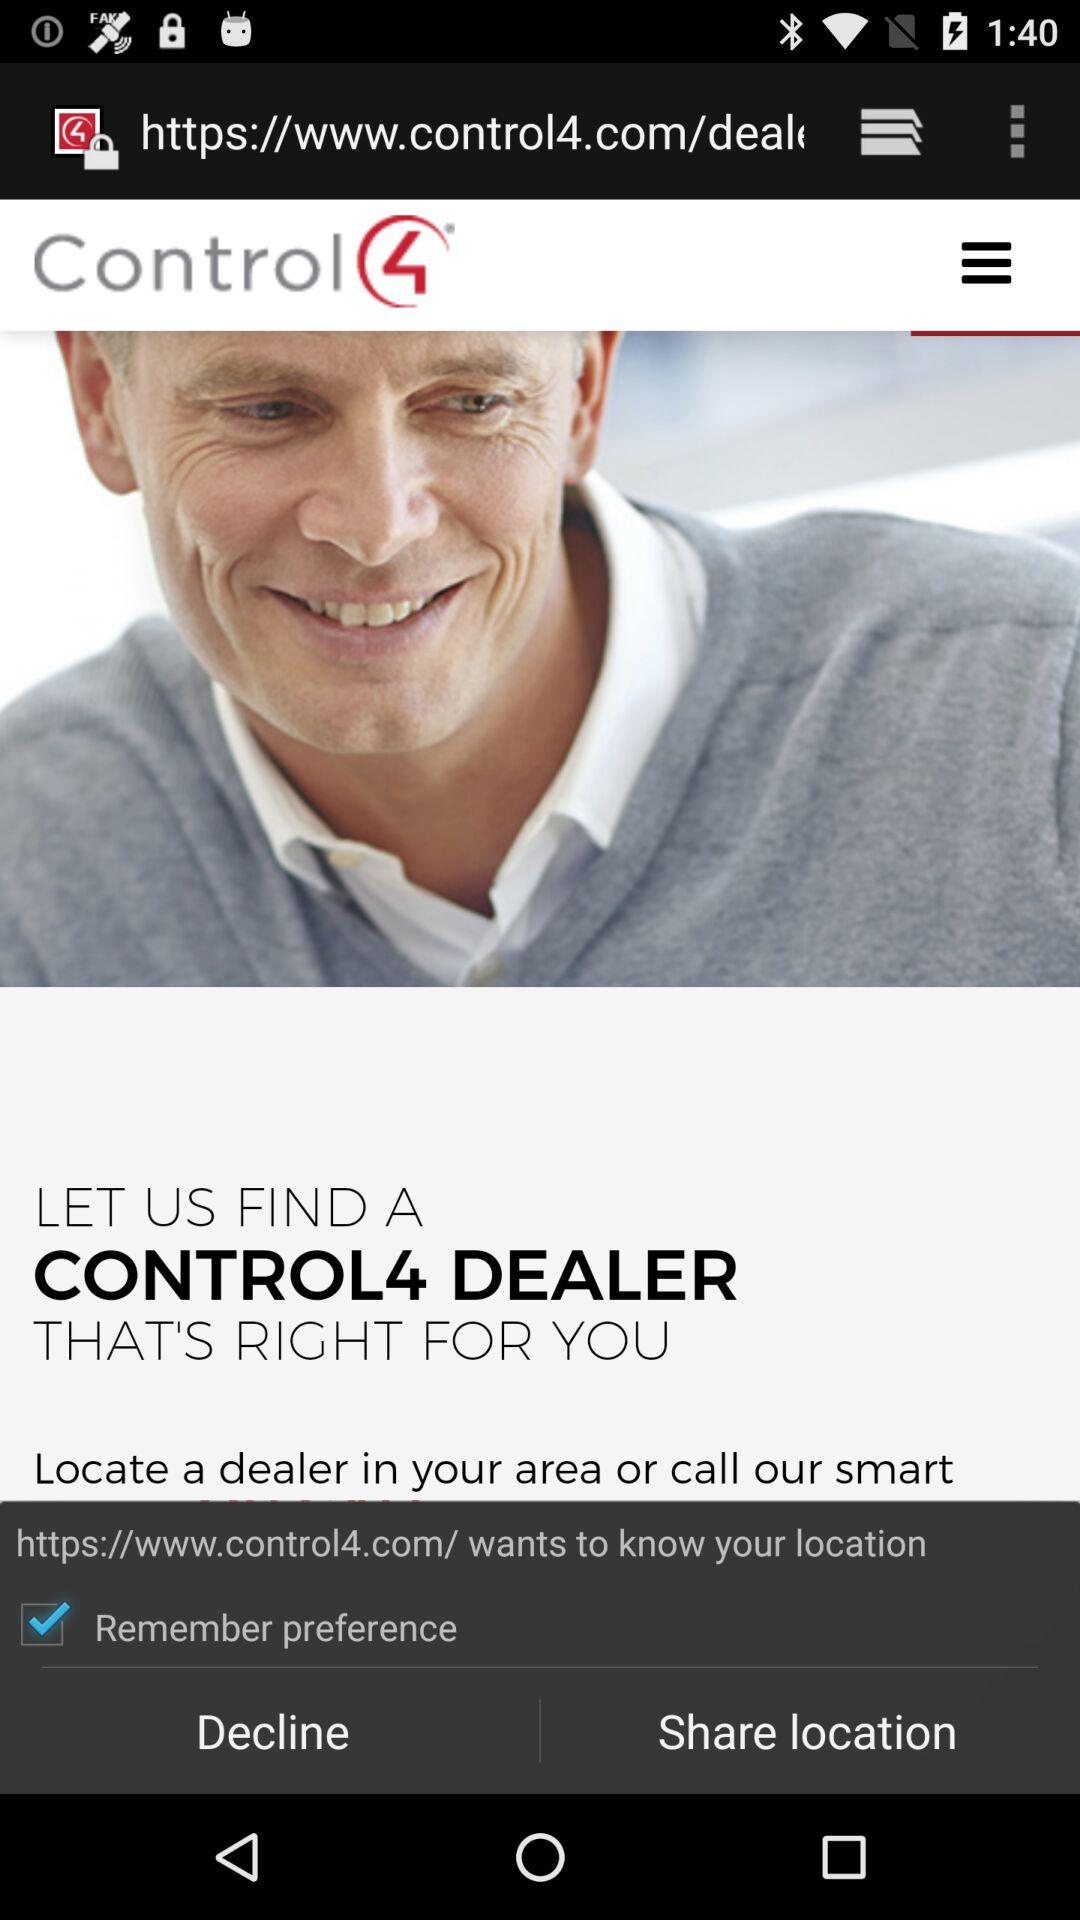What is the status of the remember prefrence? The status is "on". 